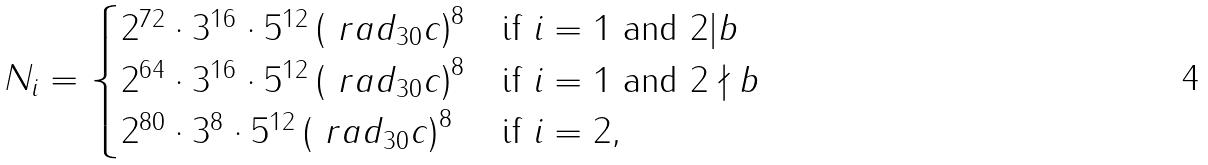<formula> <loc_0><loc_0><loc_500><loc_500>N _ { i } = \begin{cases} 2 ^ { 7 2 } \cdot 3 ^ { 1 6 } \cdot 5 ^ { 1 2 } \left ( \ r a d _ { 3 0 } c \right ) ^ { 8 } & \text {if } i = 1 \text { and } 2 | b \\ 2 ^ { 6 4 } \cdot 3 ^ { 1 6 } \cdot 5 ^ { 1 2 } \left ( \ r a d _ { 3 0 } c \right ) ^ { 8 } & \text {if } i = 1 \text { and } 2 \nmid b \\ 2 ^ { 8 0 } \cdot 3 ^ { 8 } \cdot 5 ^ { 1 2 } \left ( \ r a d _ { 3 0 } c \right ) ^ { 8 } & \text {if } i = 2 , \end{cases}</formula> 